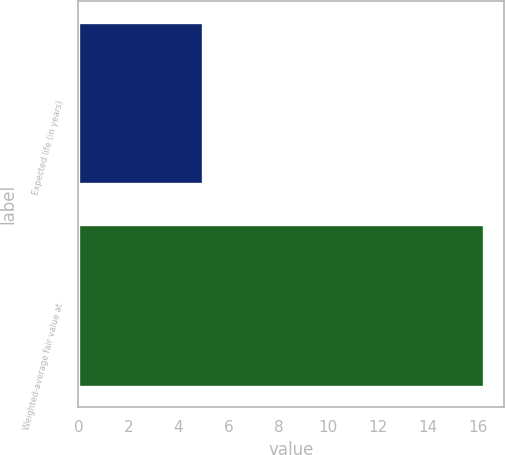Convert chart to OTSL. <chart><loc_0><loc_0><loc_500><loc_500><bar_chart><fcel>Expected life (in years)<fcel>Weighted-average fair value at<nl><fcel>5<fcel>16.22<nl></chart> 